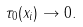<formula> <loc_0><loc_0><loc_500><loc_500>\tau _ { 0 } ( x _ { i } ) \rightarrow 0 .</formula> 